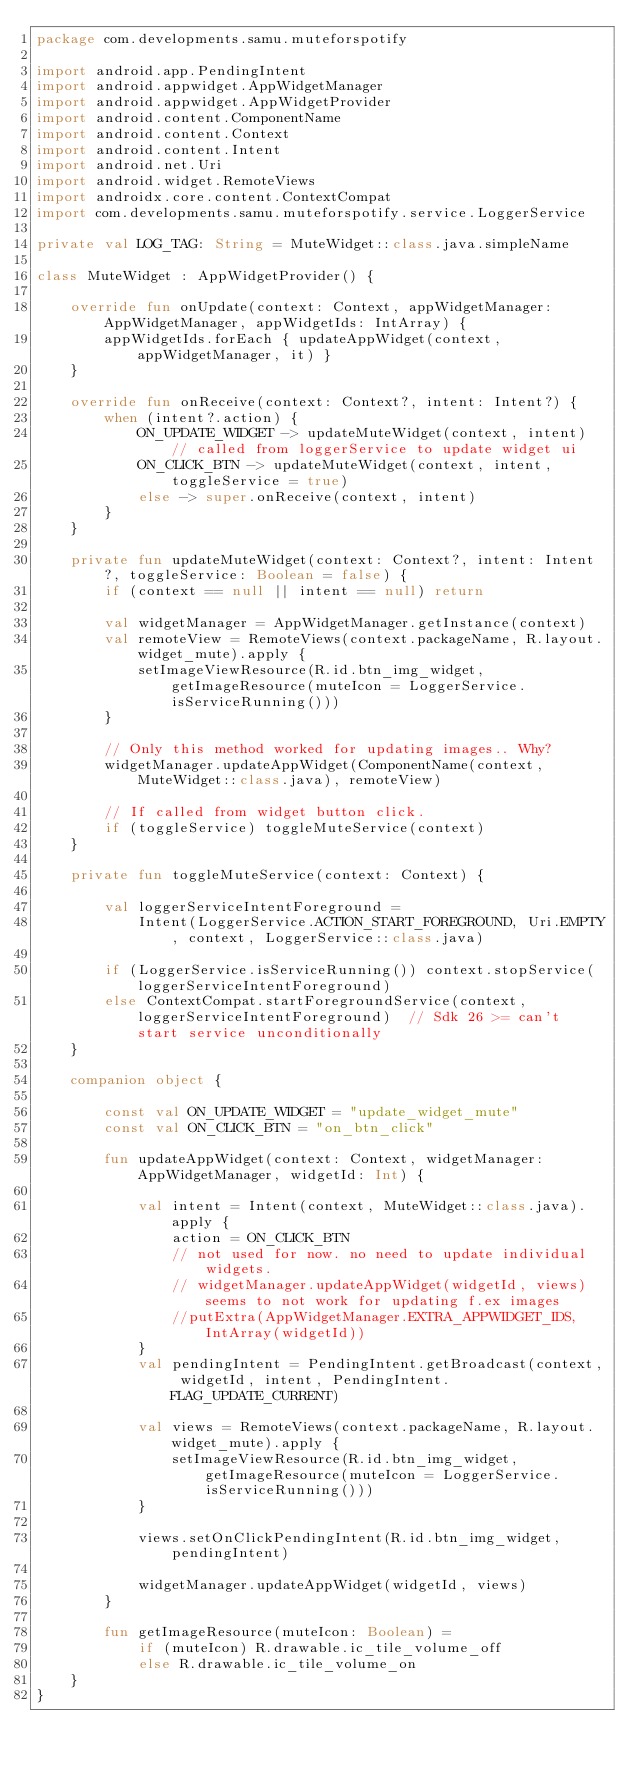Convert code to text. <code><loc_0><loc_0><loc_500><loc_500><_Kotlin_>package com.developments.samu.muteforspotify

import android.app.PendingIntent
import android.appwidget.AppWidgetManager
import android.appwidget.AppWidgetProvider
import android.content.ComponentName
import android.content.Context
import android.content.Intent
import android.net.Uri
import android.widget.RemoteViews
import androidx.core.content.ContextCompat
import com.developments.samu.muteforspotify.service.LoggerService

private val LOG_TAG: String = MuteWidget::class.java.simpleName

class MuteWidget : AppWidgetProvider() {

    override fun onUpdate(context: Context, appWidgetManager: AppWidgetManager, appWidgetIds: IntArray) {
        appWidgetIds.forEach { updateAppWidget(context, appWidgetManager, it) }
    }

    override fun onReceive(context: Context?, intent: Intent?) {
        when (intent?.action) {
            ON_UPDATE_WIDGET -> updateMuteWidget(context, intent)  // called from loggerService to update widget ui
            ON_CLICK_BTN -> updateMuteWidget(context, intent, toggleService = true)
            else -> super.onReceive(context, intent)
        }
    }

    private fun updateMuteWidget(context: Context?, intent: Intent?, toggleService: Boolean = false) {
        if (context == null || intent == null) return

        val widgetManager = AppWidgetManager.getInstance(context)
        val remoteView = RemoteViews(context.packageName, R.layout.widget_mute).apply {
            setImageViewResource(R.id.btn_img_widget, getImageResource(muteIcon = LoggerService.isServiceRunning()))
        }

        // Only this method worked for updating images.. Why?
        widgetManager.updateAppWidget(ComponentName(context, MuteWidget::class.java), remoteView)

        // If called from widget button click.
        if (toggleService) toggleMuteService(context)
    }

    private fun toggleMuteService(context: Context) {

        val loggerServiceIntentForeground =
            Intent(LoggerService.ACTION_START_FOREGROUND, Uri.EMPTY, context, LoggerService::class.java)

        if (LoggerService.isServiceRunning()) context.stopService(loggerServiceIntentForeground)
        else ContextCompat.startForegroundService(context, loggerServiceIntentForeground)  // Sdk 26 >= can't start service unconditionally
    }

    companion object {

        const val ON_UPDATE_WIDGET = "update_widget_mute"
        const val ON_CLICK_BTN = "on_btn_click"

        fun updateAppWidget(context: Context, widgetManager: AppWidgetManager, widgetId: Int) {

            val intent = Intent(context, MuteWidget::class.java).apply {
                action = ON_CLICK_BTN
                // not used for now. no need to update individual widgets.
                // widgetManager.updateAppWidget(widgetId, views) seems to not work for updating f.ex images
                //putExtra(AppWidgetManager.EXTRA_APPWIDGET_IDS, IntArray(widgetId))
            }
            val pendingIntent = PendingIntent.getBroadcast(context, widgetId, intent, PendingIntent.FLAG_UPDATE_CURRENT)

            val views = RemoteViews(context.packageName, R.layout.widget_mute).apply {
                setImageViewResource(R.id.btn_img_widget, getImageResource(muteIcon = LoggerService.isServiceRunning()))
            }

            views.setOnClickPendingIntent(R.id.btn_img_widget, pendingIntent)

            widgetManager.updateAppWidget(widgetId, views)
        }

        fun getImageResource(muteIcon: Boolean) =
            if (muteIcon) R.drawable.ic_tile_volume_off
            else R.drawable.ic_tile_volume_on
    }
}</code> 